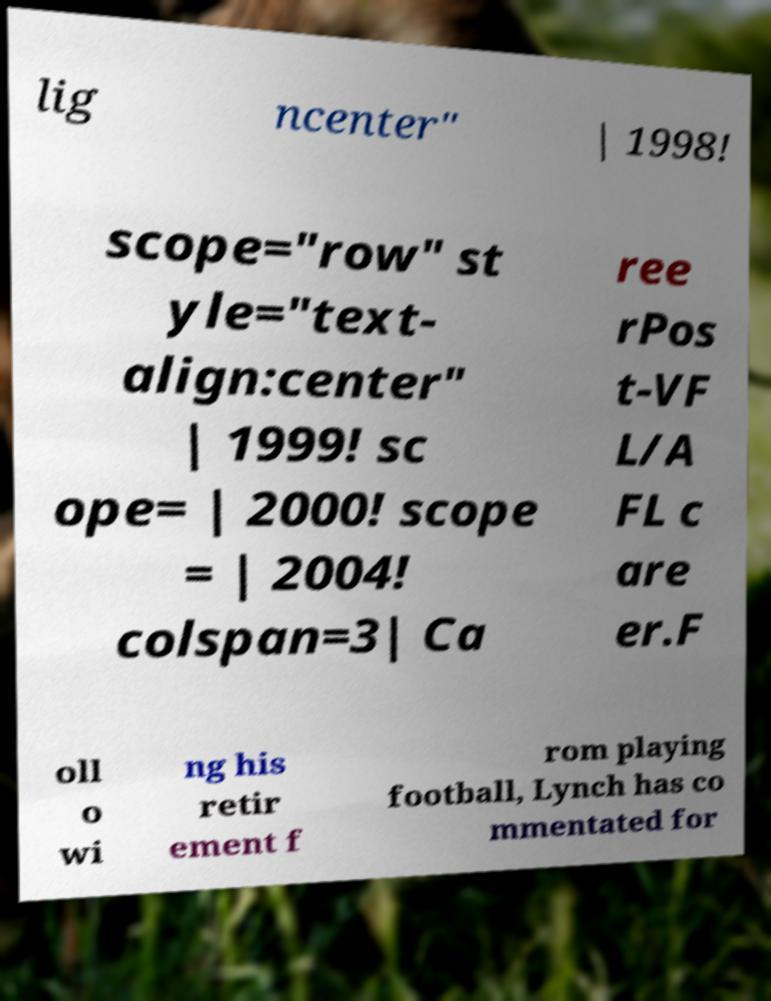There's text embedded in this image that I need extracted. Can you transcribe it verbatim? lig ncenter" | 1998! scope="row" st yle="text- align:center" | 1999! sc ope= | 2000! scope = | 2004! colspan=3| Ca ree rPos t-VF L/A FL c are er.F oll o wi ng his retir ement f rom playing football, Lynch has co mmentated for 